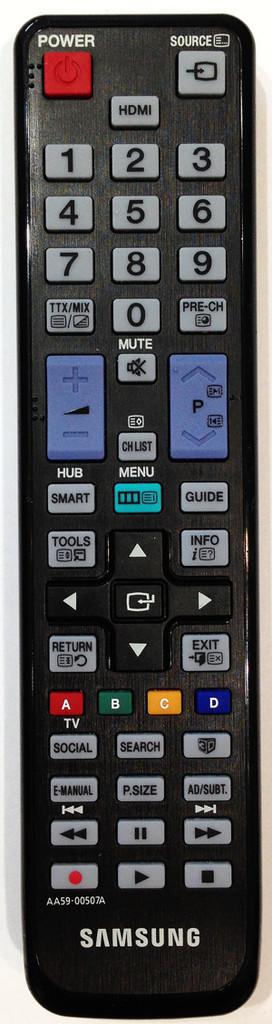What color is the remote?
Provide a succinct answer. Black. What is the word above the red button on the top left?
Provide a short and direct response. Power. 